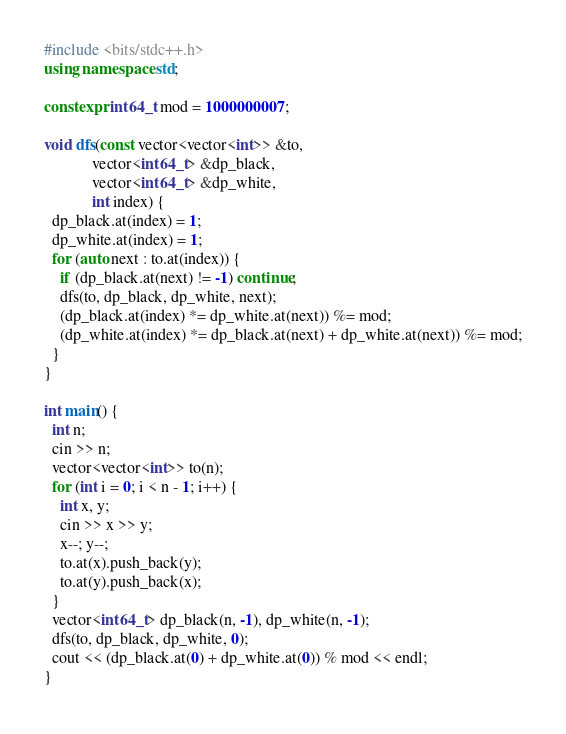Convert code to text. <code><loc_0><loc_0><loc_500><loc_500><_C++_>#include <bits/stdc++.h>
using namespace std;

constexpr int64_t mod = 1000000007;

void dfs(const vector<vector<int>> &to,
            vector<int64_t> &dp_black,
            vector<int64_t> &dp_white,
            int index) {
  dp_black.at(index) = 1;
  dp_white.at(index) = 1;
  for (auto next : to.at(index)) {
    if (dp_black.at(next) != -1) continue;
    dfs(to, dp_black, dp_white, next);
    (dp_black.at(index) *= dp_white.at(next)) %= mod;
    (dp_white.at(index) *= dp_black.at(next) + dp_white.at(next)) %= mod;
  }
}

int main() {
  int n;
  cin >> n;
  vector<vector<int>> to(n);
  for (int i = 0; i < n - 1; i++) {
    int x, y;
    cin >> x >> y;
    x--; y--;
    to.at(x).push_back(y);
    to.at(y).push_back(x);
  }
  vector<int64_t> dp_black(n, -1), dp_white(n, -1);
  dfs(to, dp_black, dp_white, 0);
  cout << (dp_black.at(0) + dp_white.at(0)) % mod << endl;
}
</code> 